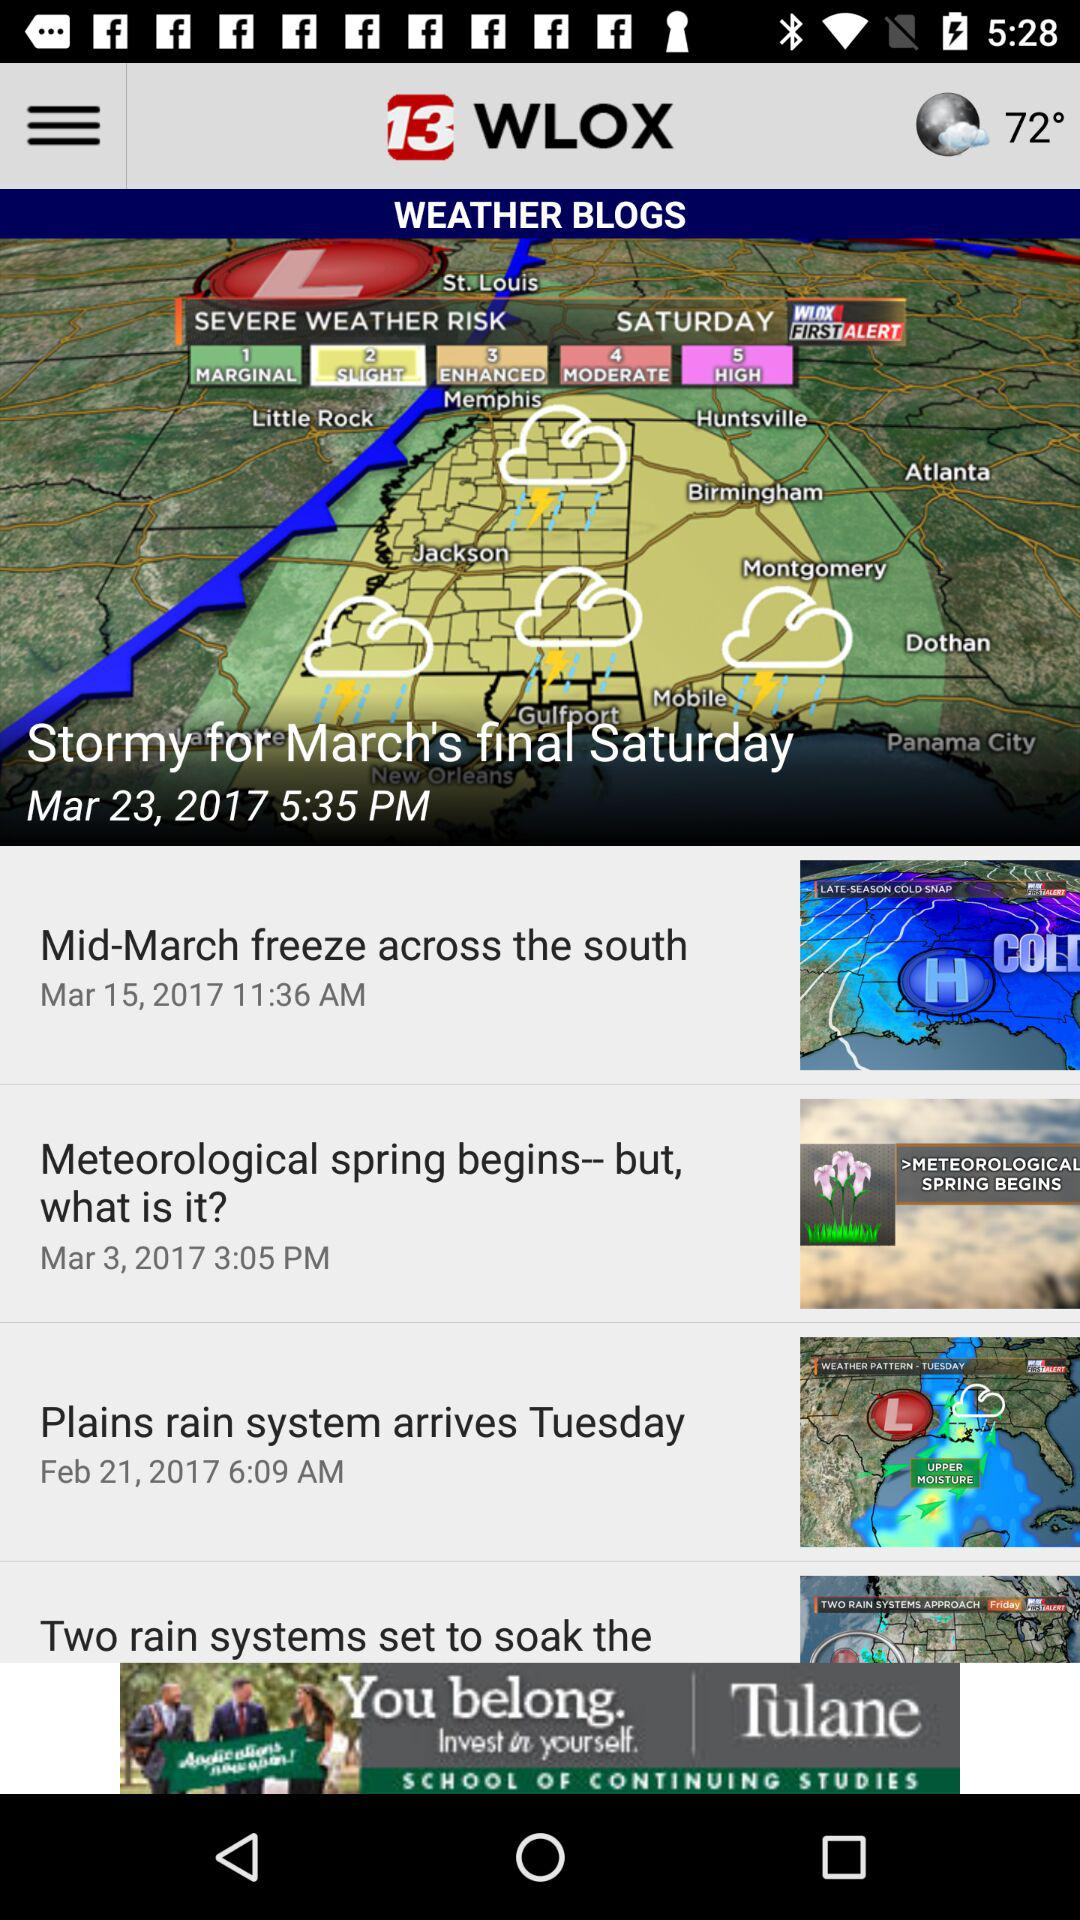Which weather blog was posted on March 3, 2017? The weather blog "Meteorological spring begins-- but, what is it?" was posted on March 3, 2017. 